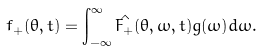<formula> <loc_0><loc_0><loc_500><loc_500>f _ { + } ( \theta , t ) = \int _ { - \infty } ^ { \infty } \hat { F _ { + } } ( \theta , \omega , t ) g ( \omega ) d \omega .</formula> 